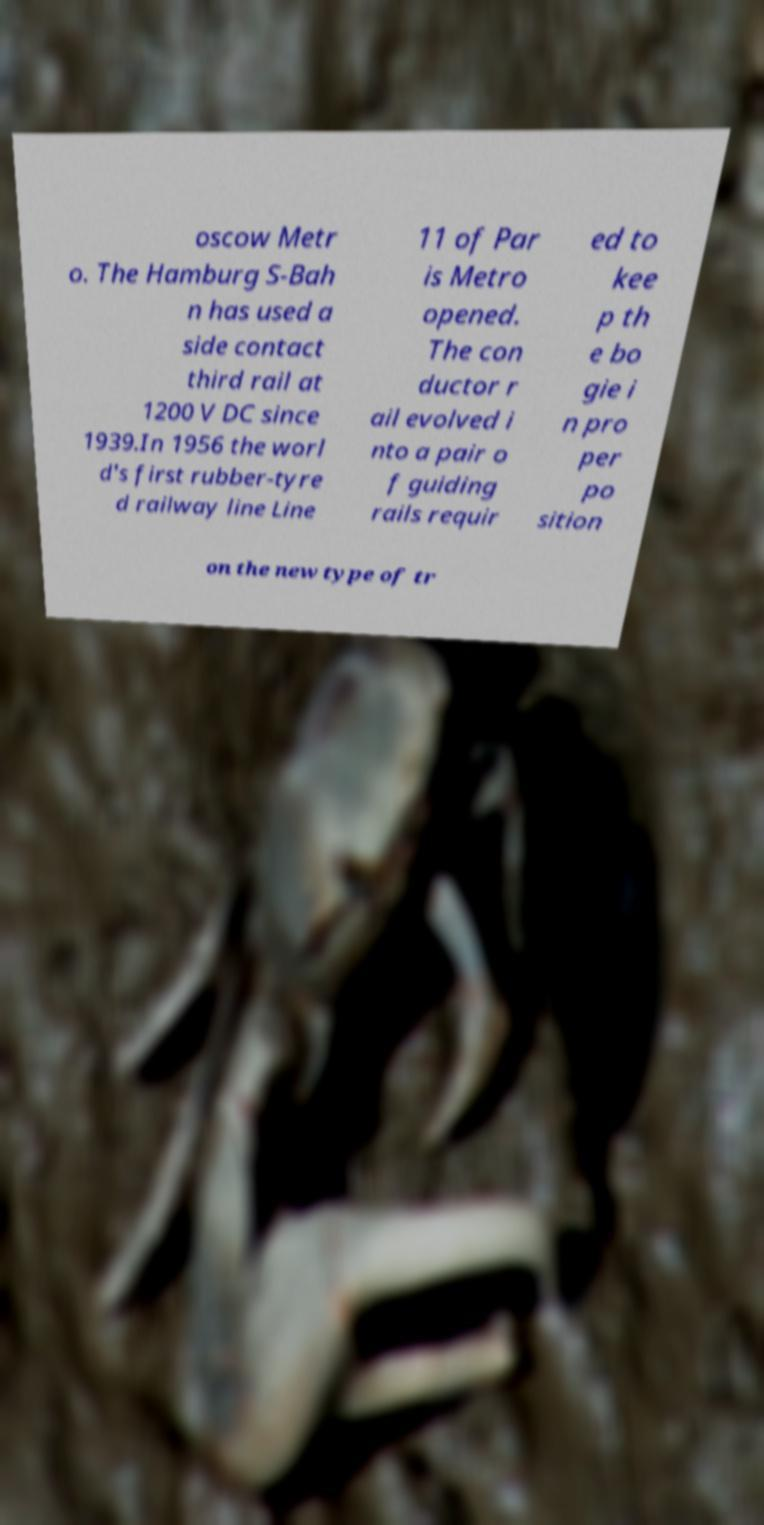Can you accurately transcribe the text from the provided image for me? oscow Metr o. The Hamburg S-Bah n has used a side contact third rail at 1200 V DC since 1939.In 1956 the worl d's first rubber-tyre d railway line Line 11 of Par is Metro opened. The con ductor r ail evolved i nto a pair o f guiding rails requir ed to kee p th e bo gie i n pro per po sition on the new type of tr 